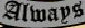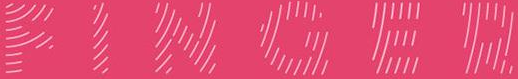What text is displayed in these images sequentially, separated by a semicolon? Always; FINGER 